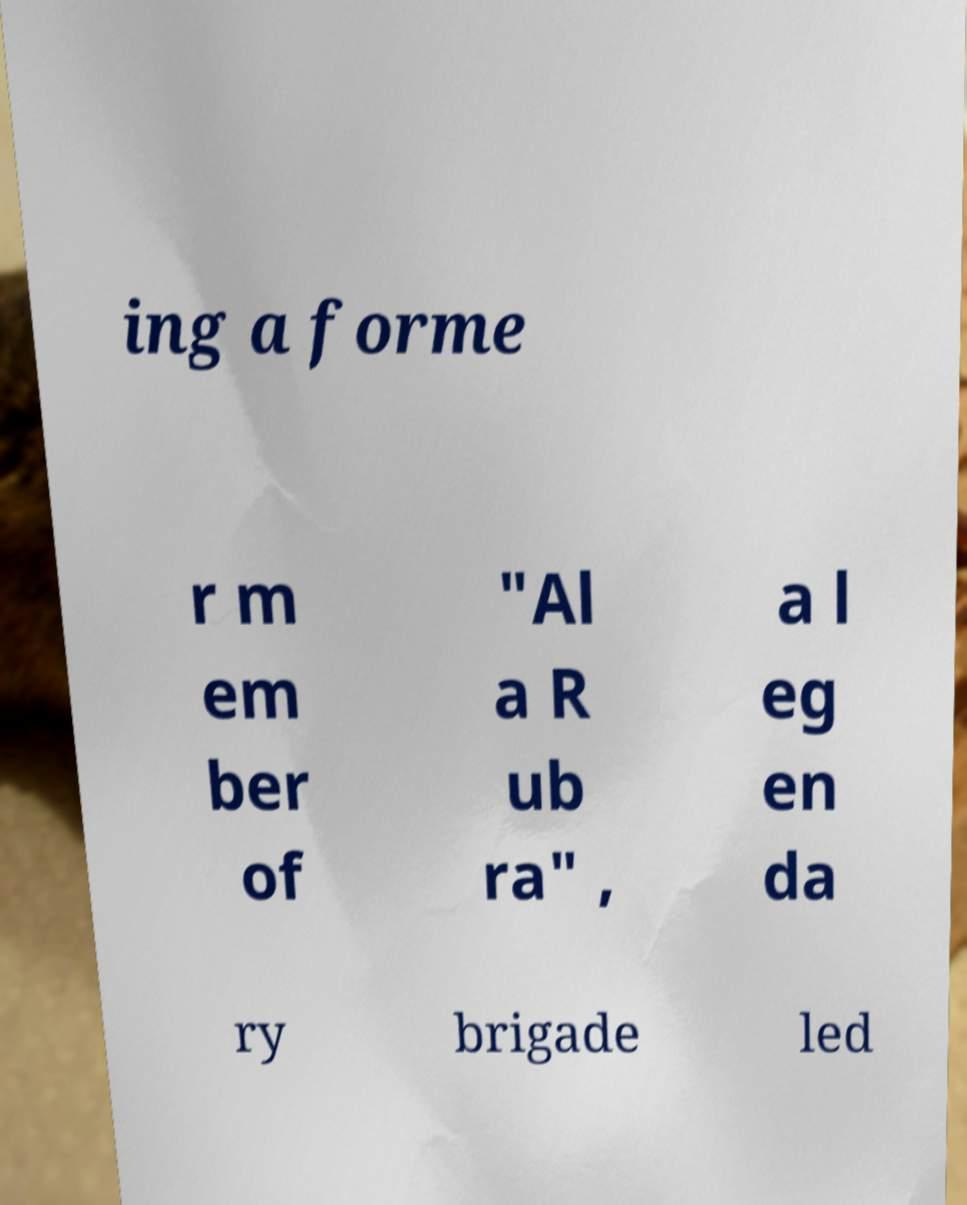What messages or text are displayed in this image? I need them in a readable, typed format. ing a forme r m em ber of "Al a R ub ra" , a l eg en da ry brigade led 